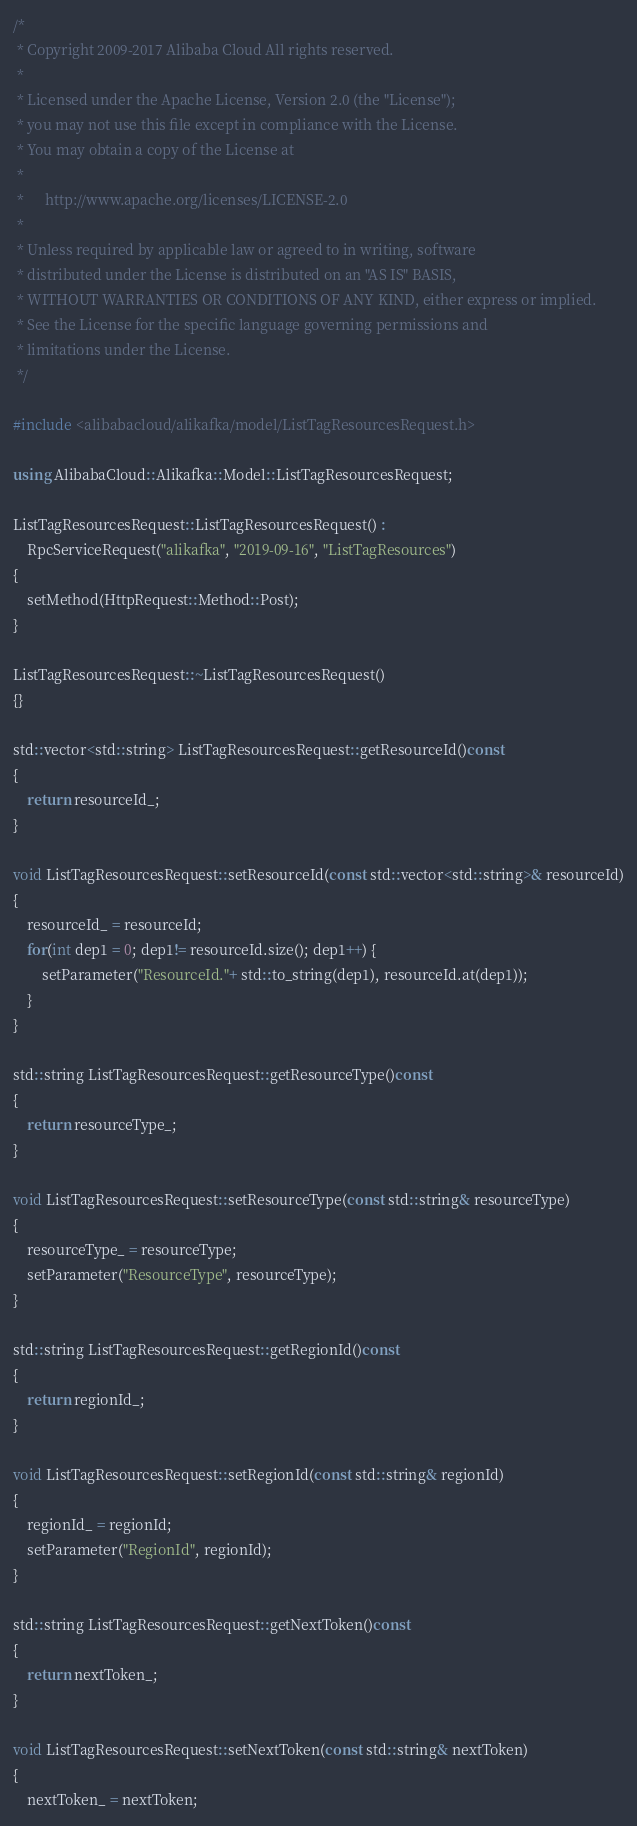Convert code to text. <code><loc_0><loc_0><loc_500><loc_500><_C++_>/*
 * Copyright 2009-2017 Alibaba Cloud All rights reserved.
 * 
 * Licensed under the Apache License, Version 2.0 (the "License");
 * you may not use this file except in compliance with the License.
 * You may obtain a copy of the License at
 * 
 *      http://www.apache.org/licenses/LICENSE-2.0
 * 
 * Unless required by applicable law or agreed to in writing, software
 * distributed under the License is distributed on an "AS IS" BASIS,
 * WITHOUT WARRANTIES OR CONDITIONS OF ANY KIND, either express or implied.
 * See the License for the specific language governing permissions and
 * limitations under the License.
 */

#include <alibabacloud/alikafka/model/ListTagResourcesRequest.h>

using AlibabaCloud::Alikafka::Model::ListTagResourcesRequest;

ListTagResourcesRequest::ListTagResourcesRequest() :
	RpcServiceRequest("alikafka", "2019-09-16", "ListTagResources")
{
	setMethod(HttpRequest::Method::Post);
}

ListTagResourcesRequest::~ListTagResourcesRequest()
{}

std::vector<std::string> ListTagResourcesRequest::getResourceId()const
{
	return resourceId_;
}

void ListTagResourcesRequest::setResourceId(const std::vector<std::string>& resourceId)
{
	resourceId_ = resourceId;
	for(int dep1 = 0; dep1!= resourceId.size(); dep1++) {
		setParameter("ResourceId."+ std::to_string(dep1), resourceId.at(dep1));
	}
}

std::string ListTagResourcesRequest::getResourceType()const
{
	return resourceType_;
}

void ListTagResourcesRequest::setResourceType(const std::string& resourceType)
{
	resourceType_ = resourceType;
	setParameter("ResourceType", resourceType);
}

std::string ListTagResourcesRequest::getRegionId()const
{
	return regionId_;
}

void ListTagResourcesRequest::setRegionId(const std::string& regionId)
{
	regionId_ = regionId;
	setParameter("RegionId", regionId);
}

std::string ListTagResourcesRequest::getNextToken()const
{
	return nextToken_;
}

void ListTagResourcesRequest::setNextToken(const std::string& nextToken)
{
	nextToken_ = nextToken;</code> 